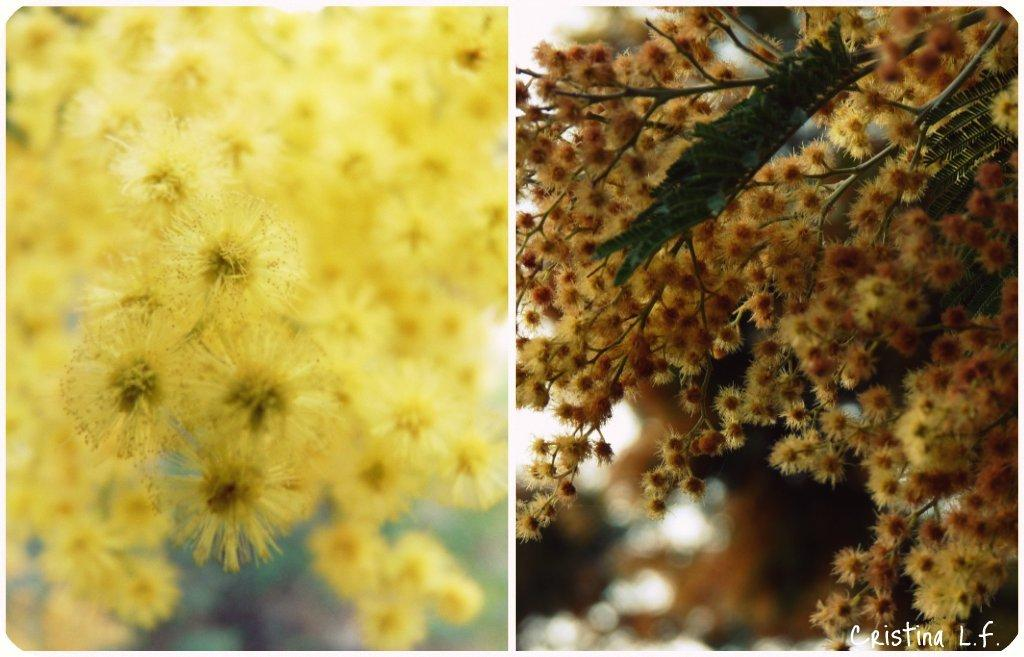What type of image is present in the picture? There is a parallax image in the picture. What is depicted in the parallax image? The parallax image contains flowers. What colors can be seen in the flowers? The flowers are in yellow and brown colors. What type of arch can be seen in the image? There is no arch present in the image; it features a parallax image with flowers. What kind of suit is the person wearing in the image? There is no person present in the image, so it is not possible to determine what type of suit they might be wearing. 